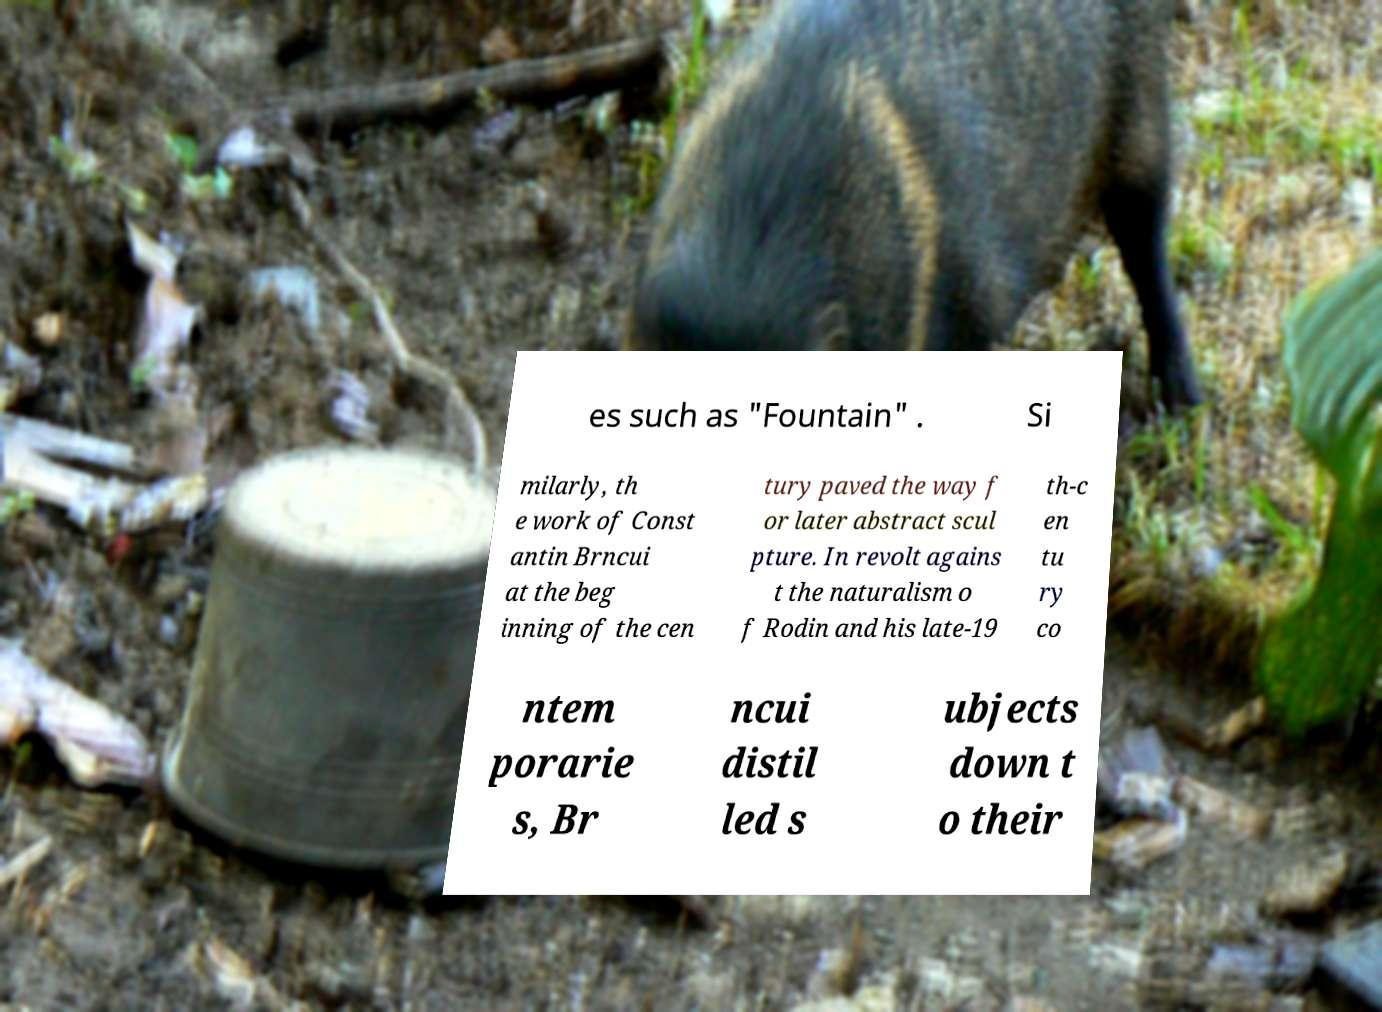There's text embedded in this image that I need extracted. Can you transcribe it verbatim? es such as "Fountain" . Si milarly, th e work of Const antin Brncui at the beg inning of the cen tury paved the way f or later abstract scul pture. In revolt agains t the naturalism o f Rodin and his late-19 th-c en tu ry co ntem porarie s, Br ncui distil led s ubjects down t o their 